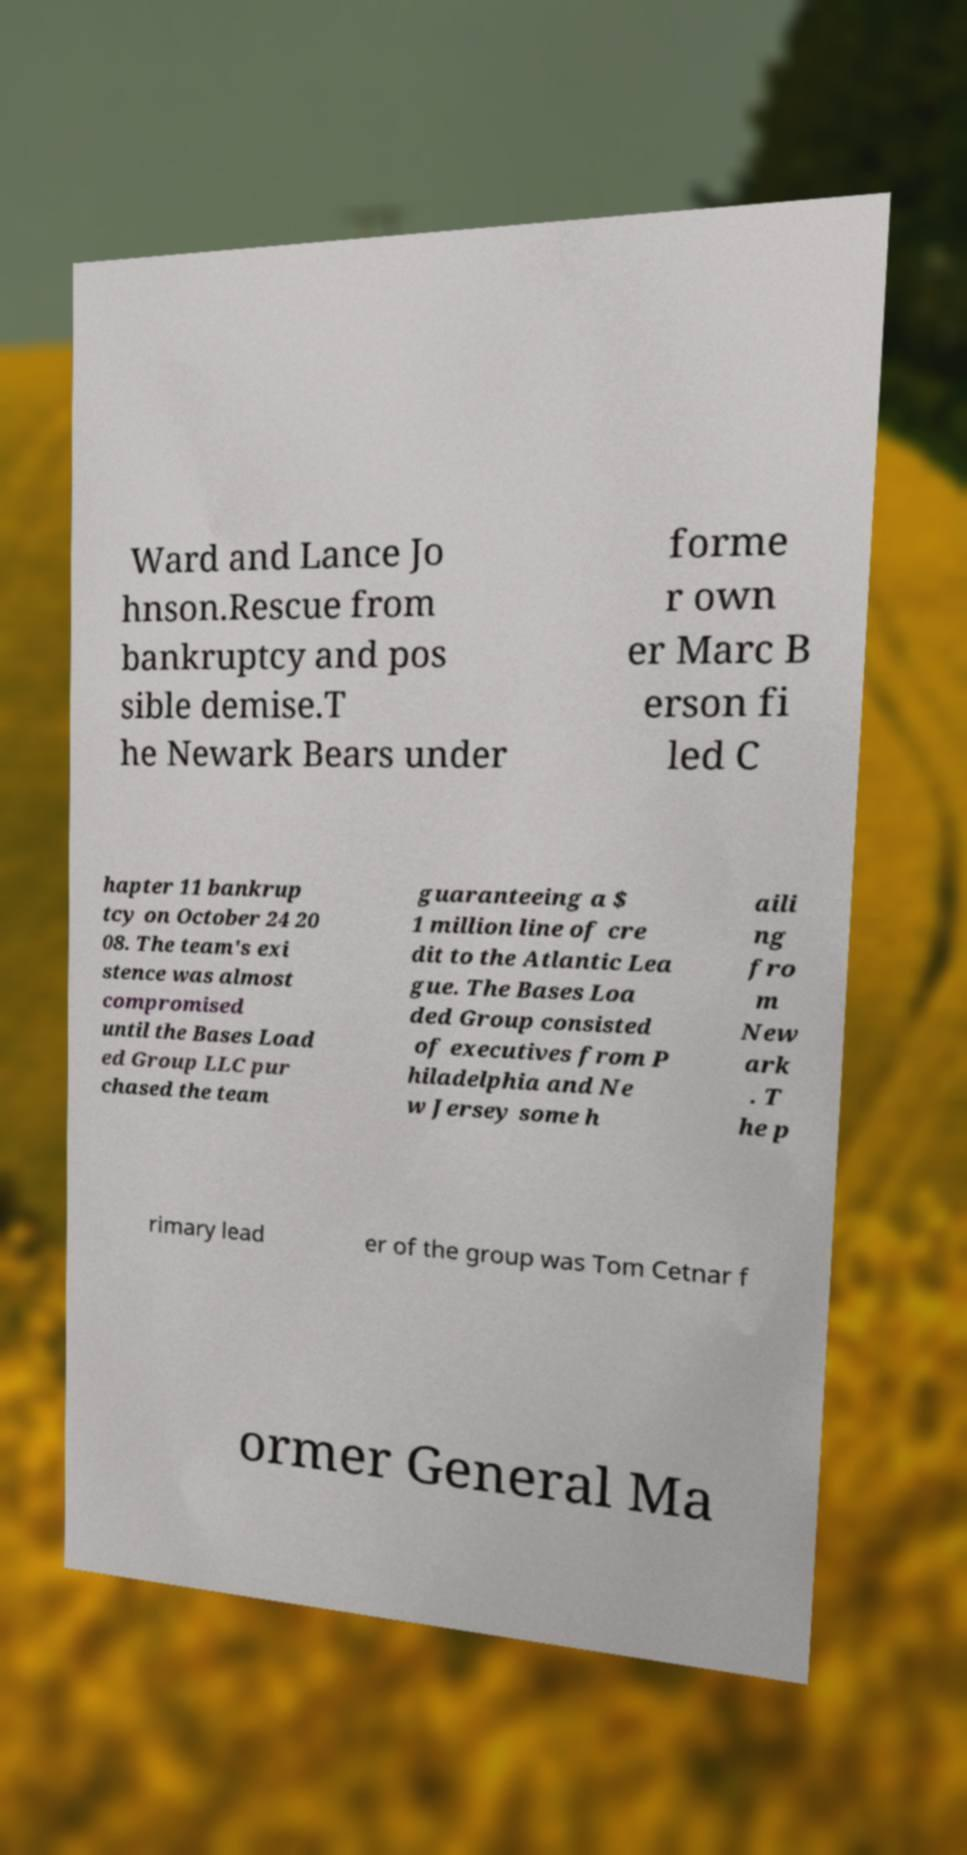There's text embedded in this image that I need extracted. Can you transcribe it verbatim? Ward and Lance Jo hnson.Rescue from bankruptcy and pos sible demise.T he Newark Bears under forme r own er Marc B erson fi led C hapter 11 bankrup tcy on October 24 20 08. The team's exi stence was almost compromised until the Bases Load ed Group LLC pur chased the team guaranteeing a $ 1 million line of cre dit to the Atlantic Lea gue. The Bases Loa ded Group consisted of executives from P hiladelphia and Ne w Jersey some h aili ng fro m New ark . T he p rimary lead er of the group was Tom Cetnar f ormer General Ma 